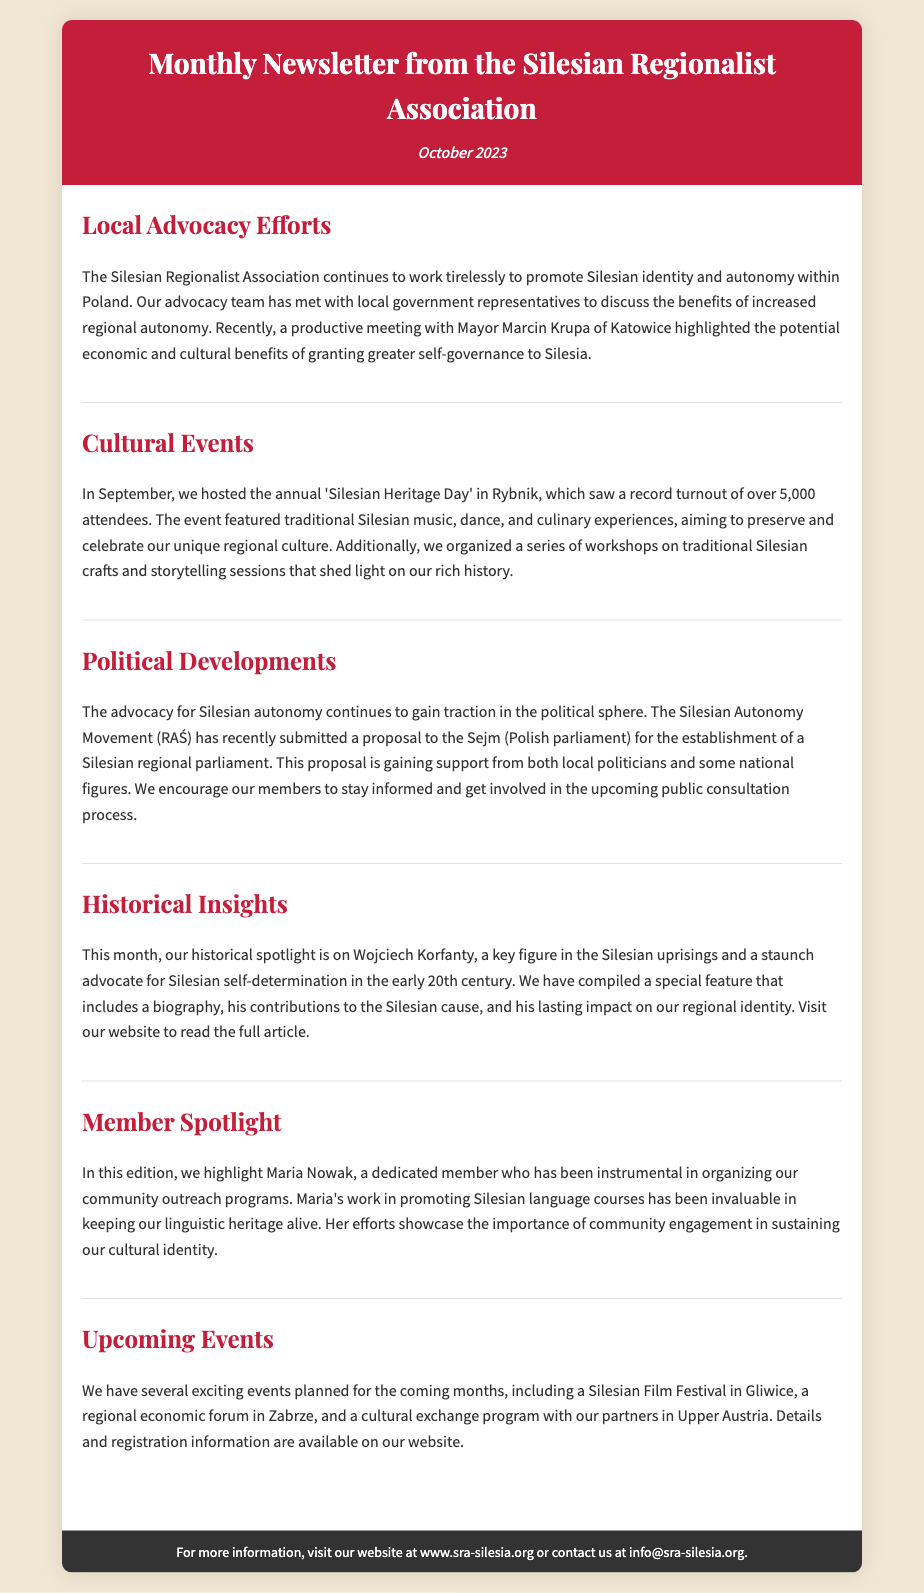what is the title of the newsletter? The title of the newsletter is stated in the header section of the document.
Answer: Monthly Newsletter from the Silesian Regionalist Association when was the Silesian Heritage Day held? The specific month and year of the event are mentioned in the cultural events section of the document.
Answer: September 2023 who highlighted the potential benefits of greater self-governance in Silesia? The document mentions a meeting with a specific mayor who discussed the benefits of autonomy.
Answer: Mayor Marcin Krupa how many attendees were at the Silesian Heritage Day? The document provides a specific number regarding the turnout for the event in Rybnik.
Answer: over 5,000 attendees who is the member spotlighted in this edition? The document specifically names a member who has made significant contributions to the association.
Answer: Maria Nowak what political body received the proposal for a Silesian regional parliament? The document references a specific government institution where the proposal was submitted.
Answer: Sejm what event is planned for Gliwice? The document lists upcoming events and identifies the location of one specific event.
Answer: Silesian Film Festival who is the key historical figure mentioned and known for self-determination? The historical insights section highlights a significant person from the early 20th century.
Answer: Wojciech Korfanty what is the website for more information? The footer section provides a specific URL for additional details.
Answer: www.sra-silesia.org 